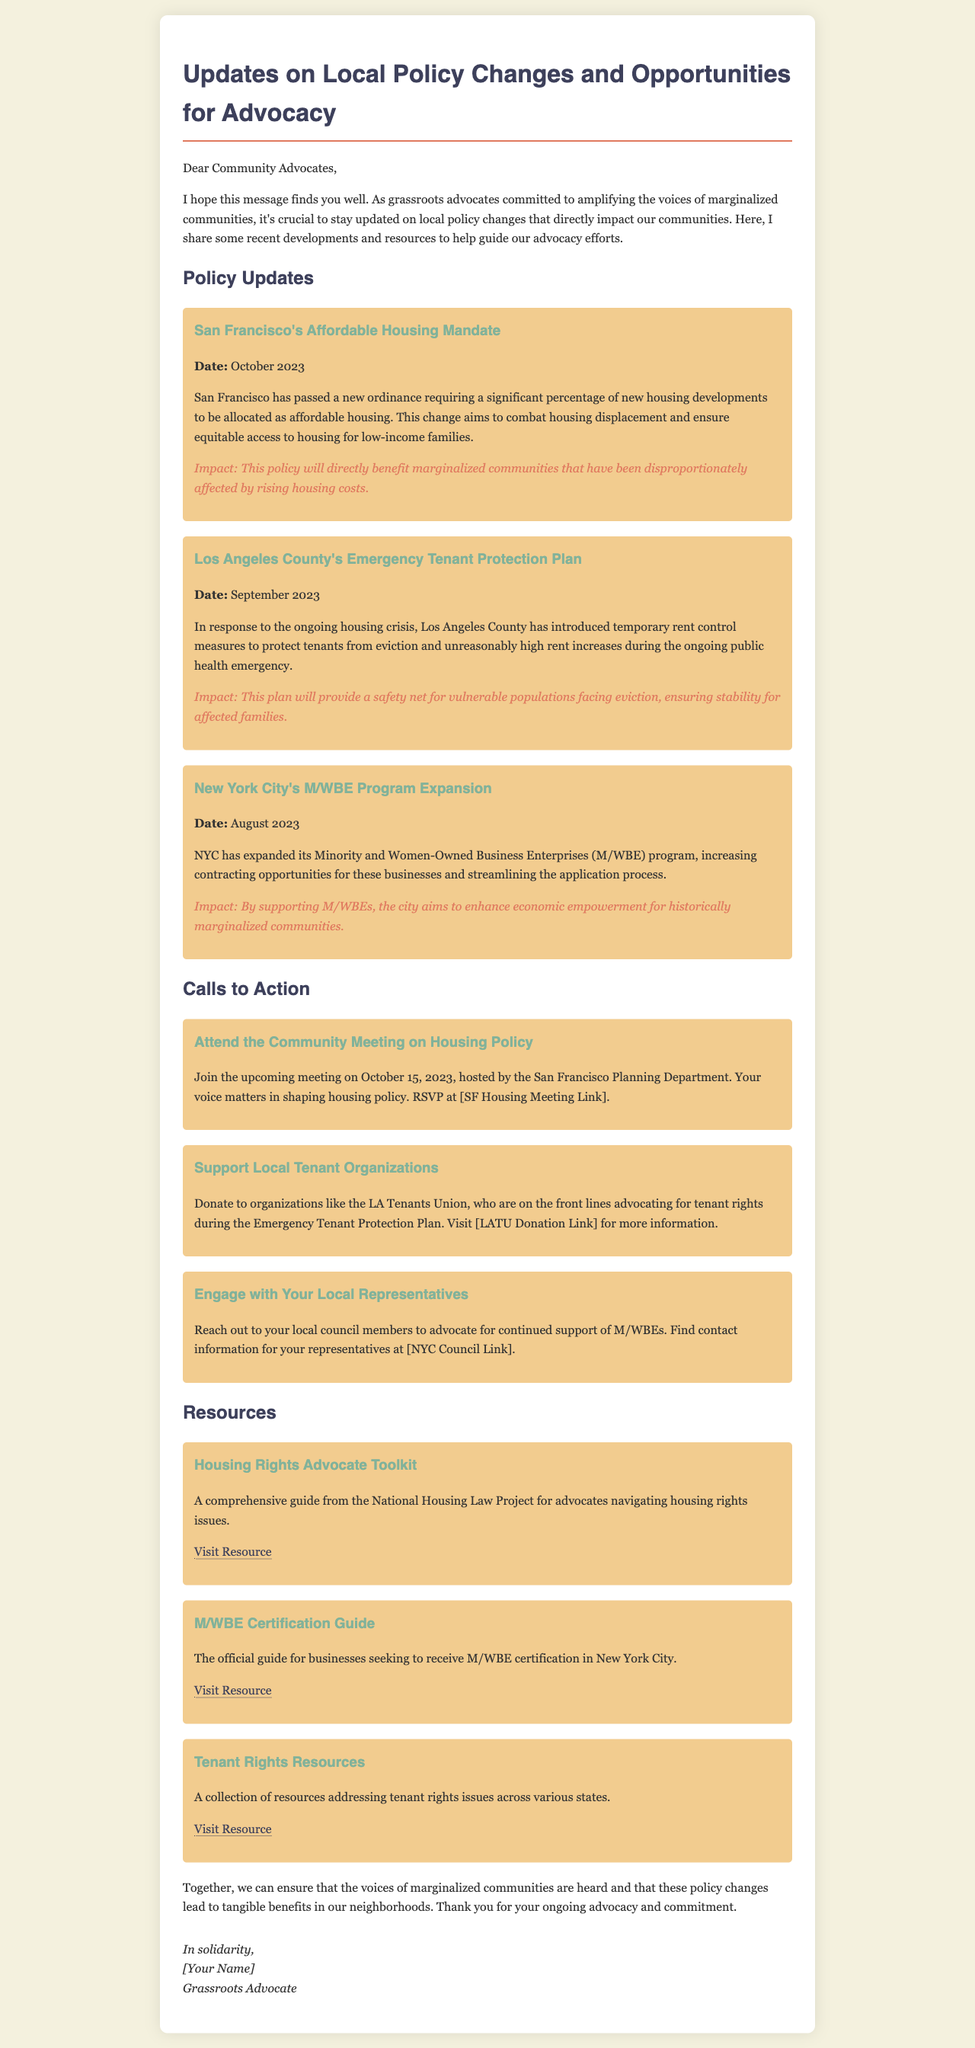What is the title of the document? The title of the document is typically found in the header section, which is "Updates on Local Policy Changes and Opportunities for Advocacy."
Answer: Updates on Local Policy Changes and Opportunities for Advocacy What is the date of the San Francisco Affordable Housing Mandate? The date is specified in the policy updates section for the San Francisco entry.
Answer: October 2023 What is the primary focus of Los Angeles County's new policy? The primary focus is indicated in the description of the policy update regarding tenant protection.
Answer: Emergency tenant protection What is the impact of New York City's M/WBE Program Expansion? The impact is given in the description of the policy updates and relates to economic empowerment.
Answer: Economic empowerment for historically marginalized communities When is the community meeting on housing policy scheduled? The meeting date is listed in the calls to action section of the document.
Answer: October 15, 2023 What organization should people support to help with tenant rights in LA? The document mentions a specific organization dedicated to tenant rights advocacy in LA.
Answer: LA Tenants Union What kind of resources does the Housing Rights Advocate Toolkit provide? The type of resources is described in the section about the toolkit, highlighting its purpose.
Answer: Comprehensive guide for advocates What action is suggested for engaging local representatives? The suggested action is provided in the calls to action as advocating for a specific program.
Answer: Advocate for continued support of M/WBEs Who is the author of the email? The author of the email is mentioned at the end of the document as part of the signature.
Answer: [Your Name] 